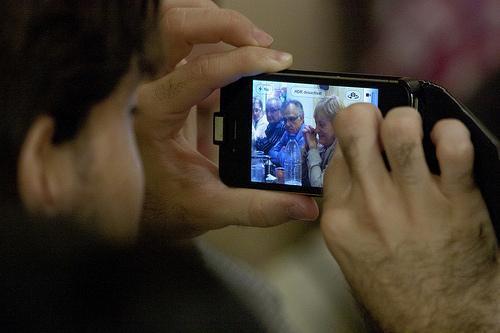How many camera the man is holding?
Give a very brief answer. 1. How many people in the camera?
Give a very brief answer. 4. 